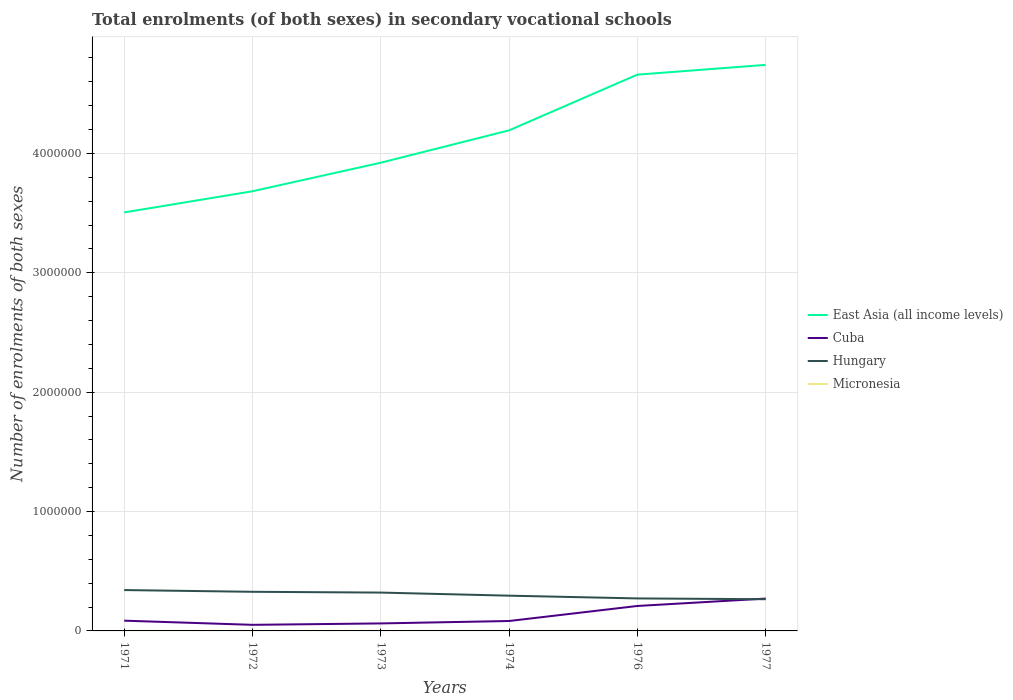How many different coloured lines are there?
Offer a very short reply. 4. Is the number of lines equal to the number of legend labels?
Provide a succinct answer. Yes. Across all years, what is the maximum number of enrolments in secondary schools in Micronesia?
Your response must be concise. 215. In which year was the number of enrolments in secondary schools in Micronesia maximum?
Provide a short and direct response. 1972. What is the total number of enrolments in secondary schools in Micronesia in the graph?
Offer a terse response. 91. What is the difference between the highest and the second highest number of enrolments in secondary schools in Micronesia?
Ensure brevity in your answer.  194. What is the difference between the highest and the lowest number of enrolments in secondary schools in Cuba?
Your answer should be compact. 2. How many lines are there?
Give a very brief answer. 4. How many years are there in the graph?
Offer a terse response. 6. Are the values on the major ticks of Y-axis written in scientific E-notation?
Ensure brevity in your answer.  No. Where does the legend appear in the graph?
Provide a succinct answer. Center right. What is the title of the graph?
Ensure brevity in your answer.  Total enrolments (of both sexes) in secondary vocational schools. Does "Senegal" appear as one of the legend labels in the graph?
Offer a very short reply. No. What is the label or title of the Y-axis?
Provide a succinct answer. Number of enrolments of both sexes. What is the Number of enrolments of both sexes in East Asia (all income levels) in 1971?
Make the answer very short. 3.51e+06. What is the Number of enrolments of both sexes of Cuba in 1971?
Offer a terse response. 8.59e+04. What is the Number of enrolments of both sexes of Hungary in 1971?
Make the answer very short. 3.42e+05. What is the Number of enrolments of both sexes of Micronesia in 1971?
Provide a short and direct response. 409. What is the Number of enrolments of both sexes of East Asia (all income levels) in 1972?
Your answer should be compact. 3.68e+06. What is the Number of enrolments of both sexes of Cuba in 1972?
Offer a very short reply. 5.10e+04. What is the Number of enrolments of both sexes in Hungary in 1972?
Your response must be concise. 3.28e+05. What is the Number of enrolments of both sexes of Micronesia in 1972?
Offer a very short reply. 215. What is the Number of enrolments of both sexes of East Asia (all income levels) in 1973?
Your response must be concise. 3.92e+06. What is the Number of enrolments of both sexes of Cuba in 1973?
Make the answer very short. 6.28e+04. What is the Number of enrolments of both sexes in Hungary in 1973?
Provide a short and direct response. 3.21e+05. What is the Number of enrolments of both sexes of Micronesia in 1973?
Offer a very short reply. 226. What is the Number of enrolments of both sexes in East Asia (all income levels) in 1974?
Keep it short and to the point. 4.19e+06. What is the Number of enrolments of both sexes in Cuba in 1974?
Your answer should be very brief. 8.31e+04. What is the Number of enrolments of both sexes of Hungary in 1974?
Keep it short and to the point. 2.95e+05. What is the Number of enrolments of both sexes in Micronesia in 1974?
Give a very brief answer. 222. What is the Number of enrolments of both sexes of East Asia (all income levels) in 1976?
Ensure brevity in your answer.  4.66e+06. What is the Number of enrolments of both sexes of Cuba in 1976?
Your answer should be compact. 2.09e+05. What is the Number of enrolments of both sexes of Hungary in 1976?
Your answer should be compact. 2.72e+05. What is the Number of enrolments of both sexes of Micronesia in 1976?
Ensure brevity in your answer.  318. What is the Number of enrolments of both sexes of East Asia (all income levels) in 1977?
Ensure brevity in your answer.  4.74e+06. What is the Number of enrolments of both sexes in Cuba in 1977?
Your answer should be compact. 2.71e+05. What is the Number of enrolments of both sexes in Hungary in 1977?
Your answer should be compact. 2.66e+05. What is the Number of enrolments of both sexes in Micronesia in 1977?
Ensure brevity in your answer.  318. Across all years, what is the maximum Number of enrolments of both sexes in East Asia (all income levels)?
Your response must be concise. 4.74e+06. Across all years, what is the maximum Number of enrolments of both sexes in Cuba?
Keep it short and to the point. 2.71e+05. Across all years, what is the maximum Number of enrolments of both sexes of Hungary?
Provide a short and direct response. 3.42e+05. Across all years, what is the maximum Number of enrolments of both sexes of Micronesia?
Your answer should be very brief. 409. Across all years, what is the minimum Number of enrolments of both sexes in East Asia (all income levels)?
Provide a succinct answer. 3.51e+06. Across all years, what is the minimum Number of enrolments of both sexes in Cuba?
Make the answer very short. 5.10e+04. Across all years, what is the minimum Number of enrolments of both sexes of Hungary?
Your response must be concise. 2.66e+05. Across all years, what is the minimum Number of enrolments of both sexes in Micronesia?
Make the answer very short. 215. What is the total Number of enrolments of both sexes in East Asia (all income levels) in the graph?
Offer a very short reply. 2.47e+07. What is the total Number of enrolments of both sexes of Cuba in the graph?
Your response must be concise. 7.63e+05. What is the total Number of enrolments of both sexes of Hungary in the graph?
Your answer should be compact. 1.82e+06. What is the total Number of enrolments of both sexes in Micronesia in the graph?
Offer a terse response. 1708. What is the difference between the Number of enrolments of both sexes in East Asia (all income levels) in 1971 and that in 1972?
Provide a succinct answer. -1.77e+05. What is the difference between the Number of enrolments of both sexes in Cuba in 1971 and that in 1972?
Offer a terse response. 3.49e+04. What is the difference between the Number of enrolments of both sexes in Hungary in 1971 and that in 1972?
Offer a terse response. 1.45e+04. What is the difference between the Number of enrolments of both sexes of Micronesia in 1971 and that in 1972?
Offer a very short reply. 194. What is the difference between the Number of enrolments of both sexes of East Asia (all income levels) in 1971 and that in 1973?
Your response must be concise. -4.17e+05. What is the difference between the Number of enrolments of both sexes in Cuba in 1971 and that in 1973?
Provide a short and direct response. 2.31e+04. What is the difference between the Number of enrolments of both sexes in Hungary in 1971 and that in 1973?
Offer a very short reply. 2.11e+04. What is the difference between the Number of enrolments of both sexes of Micronesia in 1971 and that in 1973?
Offer a terse response. 183. What is the difference between the Number of enrolments of both sexes in East Asia (all income levels) in 1971 and that in 1974?
Give a very brief answer. -6.88e+05. What is the difference between the Number of enrolments of both sexes in Cuba in 1971 and that in 1974?
Your answer should be very brief. 2764. What is the difference between the Number of enrolments of both sexes of Hungary in 1971 and that in 1974?
Make the answer very short. 4.70e+04. What is the difference between the Number of enrolments of both sexes in Micronesia in 1971 and that in 1974?
Ensure brevity in your answer.  187. What is the difference between the Number of enrolments of both sexes of East Asia (all income levels) in 1971 and that in 1976?
Provide a succinct answer. -1.15e+06. What is the difference between the Number of enrolments of both sexes of Cuba in 1971 and that in 1976?
Offer a terse response. -1.23e+05. What is the difference between the Number of enrolments of both sexes of Hungary in 1971 and that in 1976?
Provide a short and direct response. 7.01e+04. What is the difference between the Number of enrolments of both sexes in Micronesia in 1971 and that in 1976?
Your response must be concise. 91. What is the difference between the Number of enrolments of both sexes in East Asia (all income levels) in 1971 and that in 1977?
Make the answer very short. -1.24e+06. What is the difference between the Number of enrolments of both sexes of Cuba in 1971 and that in 1977?
Give a very brief answer. -1.85e+05. What is the difference between the Number of enrolments of both sexes in Hungary in 1971 and that in 1977?
Provide a short and direct response. 7.68e+04. What is the difference between the Number of enrolments of both sexes in Micronesia in 1971 and that in 1977?
Provide a succinct answer. 91. What is the difference between the Number of enrolments of both sexes of East Asia (all income levels) in 1972 and that in 1973?
Provide a short and direct response. -2.39e+05. What is the difference between the Number of enrolments of both sexes of Cuba in 1972 and that in 1973?
Ensure brevity in your answer.  -1.18e+04. What is the difference between the Number of enrolments of both sexes of Hungary in 1972 and that in 1973?
Offer a terse response. 6551. What is the difference between the Number of enrolments of both sexes of Micronesia in 1972 and that in 1973?
Keep it short and to the point. -11. What is the difference between the Number of enrolments of both sexes in East Asia (all income levels) in 1972 and that in 1974?
Provide a succinct answer. -5.10e+05. What is the difference between the Number of enrolments of both sexes in Cuba in 1972 and that in 1974?
Provide a short and direct response. -3.21e+04. What is the difference between the Number of enrolments of both sexes of Hungary in 1972 and that in 1974?
Give a very brief answer. 3.25e+04. What is the difference between the Number of enrolments of both sexes of East Asia (all income levels) in 1972 and that in 1976?
Keep it short and to the point. -9.77e+05. What is the difference between the Number of enrolments of both sexes in Cuba in 1972 and that in 1976?
Offer a very short reply. -1.58e+05. What is the difference between the Number of enrolments of both sexes of Hungary in 1972 and that in 1976?
Provide a succinct answer. 5.56e+04. What is the difference between the Number of enrolments of both sexes in Micronesia in 1972 and that in 1976?
Provide a short and direct response. -103. What is the difference between the Number of enrolments of both sexes in East Asia (all income levels) in 1972 and that in 1977?
Give a very brief answer. -1.06e+06. What is the difference between the Number of enrolments of both sexes in Cuba in 1972 and that in 1977?
Offer a very short reply. -2.20e+05. What is the difference between the Number of enrolments of both sexes of Hungary in 1972 and that in 1977?
Provide a succinct answer. 6.22e+04. What is the difference between the Number of enrolments of both sexes in Micronesia in 1972 and that in 1977?
Make the answer very short. -103. What is the difference between the Number of enrolments of both sexes of East Asia (all income levels) in 1973 and that in 1974?
Provide a succinct answer. -2.71e+05. What is the difference between the Number of enrolments of both sexes in Cuba in 1973 and that in 1974?
Offer a very short reply. -2.03e+04. What is the difference between the Number of enrolments of both sexes of Hungary in 1973 and that in 1974?
Ensure brevity in your answer.  2.59e+04. What is the difference between the Number of enrolments of both sexes in East Asia (all income levels) in 1973 and that in 1976?
Offer a very short reply. -7.38e+05. What is the difference between the Number of enrolments of both sexes in Cuba in 1973 and that in 1976?
Your answer should be compact. -1.46e+05. What is the difference between the Number of enrolments of both sexes in Hungary in 1973 and that in 1976?
Offer a terse response. 4.90e+04. What is the difference between the Number of enrolments of both sexes of Micronesia in 1973 and that in 1976?
Provide a short and direct response. -92. What is the difference between the Number of enrolments of both sexes in East Asia (all income levels) in 1973 and that in 1977?
Provide a succinct answer. -8.20e+05. What is the difference between the Number of enrolments of both sexes of Cuba in 1973 and that in 1977?
Offer a terse response. -2.08e+05. What is the difference between the Number of enrolments of both sexes in Hungary in 1973 and that in 1977?
Offer a terse response. 5.57e+04. What is the difference between the Number of enrolments of both sexes of Micronesia in 1973 and that in 1977?
Ensure brevity in your answer.  -92. What is the difference between the Number of enrolments of both sexes of East Asia (all income levels) in 1974 and that in 1976?
Your answer should be compact. -4.67e+05. What is the difference between the Number of enrolments of both sexes in Cuba in 1974 and that in 1976?
Ensure brevity in your answer.  -1.26e+05. What is the difference between the Number of enrolments of both sexes of Hungary in 1974 and that in 1976?
Provide a short and direct response. 2.31e+04. What is the difference between the Number of enrolments of both sexes in Micronesia in 1974 and that in 1976?
Offer a terse response. -96. What is the difference between the Number of enrolments of both sexes in East Asia (all income levels) in 1974 and that in 1977?
Give a very brief answer. -5.49e+05. What is the difference between the Number of enrolments of both sexes in Cuba in 1974 and that in 1977?
Your answer should be compact. -1.88e+05. What is the difference between the Number of enrolments of both sexes of Hungary in 1974 and that in 1977?
Ensure brevity in your answer.  2.97e+04. What is the difference between the Number of enrolments of both sexes of Micronesia in 1974 and that in 1977?
Offer a very short reply. -96. What is the difference between the Number of enrolments of both sexes in East Asia (all income levels) in 1976 and that in 1977?
Your answer should be very brief. -8.19e+04. What is the difference between the Number of enrolments of both sexes of Cuba in 1976 and that in 1977?
Keep it short and to the point. -6.19e+04. What is the difference between the Number of enrolments of both sexes of Hungary in 1976 and that in 1977?
Your response must be concise. 6666. What is the difference between the Number of enrolments of both sexes of Micronesia in 1976 and that in 1977?
Keep it short and to the point. 0. What is the difference between the Number of enrolments of both sexes in East Asia (all income levels) in 1971 and the Number of enrolments of both sexes in Cuba in 1972?
Your answer should be very brief. 3.45e+06. What is the difference between the Number of enrolments of both sexes of East Asia (all income levels) in 1971 and the Number of enrolments of both sexes of Hungary in 1972?
Your answer should be compact. 3.18e+06. What is the difference between the Number of enrolments of both sexes in East Asia (all income levels) in 1971 and the Number of enrolments of both sexes in Micronesia in 1972?
Your response must be concise. 3.51e+06. What is the difference between the Number of enrolments of both sexes of Cuba in 1971 and the Number of enrolments of both sexes of Hungary in 1972?
Provide a short and direct response. -2.42e+05. What is the difference between the Number of enrolments of both sexes in Cuba in 1971 and the Number of enrolments of both sexes in Micronesia in 1972?
Offer a very short reply. 8.56e+04. What is the difference between the Number of enrolments of both sexes in Hungary in 1971 and the Number of enrolments of both sexes in Micronesia in 1972?
Provide a succinct answer. 3.42e+05. What is the difference between the Number of enrolments of both sexes in East Asia (all income levels) in 1971 and the Number of enrolments of both sexes in Cuba in 1973?
Keep it short and to the point. 3.44e+06. What is the difference between the Number of enrolments of both sexes in East Asia (all income levels) in 1971 and the Number of enrolments of both sexes in Hungary in 1973?
Ensure brevity in your answer.  3.18e+06. What is the difference between the Number of enrolments of both sexes in East Asia (all income levels) in 1971 and the Number of enrolments of both sexes in Micronesia in 1973?
Provide a short and direct response. 3.51e+06. What is the difference between the Number of enrolments of both sexes in Cuba in 1971 and the Number of enrolments of both sexes in Hungary in 1973?
Offer a terse response. -2.35e+05. What is the difference between the Number of enrolments of both sexes of Cuba in 1971 and the Number of enrolments of both sexes of Micronesia in 1973?
Ensure brevity in your answer.  8.56e+04. What is the difference between the Number of enrolments of both sexes of Hungary in 1971 and the Number of enrolments of both sexes of Micronesia in 1973?
Your answer should be compact. 3.42e+05. What is the difference between the Number of enrolments of both sexes in East Asia (all income levels) in 1971 and the Number of enrolments of both sexes in Cuba in 1974?
Offer a very short reply. 3.42e+06. What is the difference between the Number of enrolments of both sexes of East Asia (all income levels) in 1971 and the Number of enrolments of both sexes of Hungary in 1974?
Ensure brevity in your answer.  3.21e+06. What is the difference between the Number of enrolments of both sexes of East Asia (all income levels) in 1971 and the Number of enrolments of both sexes of Micronesia in 1974?
Make the answer very short. 3.51e+06. What is the difference between the Number of enrolments of both sexes of Cuba in 1971 and the Number of enrolments of both sexes of Hungary in 1974?
Offer a very short reply. -2.09e+05. What is the difference between the Number of enrolments of both sexes in Cuba in 1971 and the Number of enrolments of both sexes in Micronesia in 1974?
Provide a short and direct response. 8.56e+04. What is the difference between the Number of enrolments of both sexes of Hungary in 1971 and the Number of enrolments of both sexes of Micronesia in 1974?
Offer a very short reply. 3.42e+05. What is the difference between the Number of enrolments of both sexes in East Asia (all income levels) in 1971 and the Number of enrolments of both sexes in Cuba in 1976?
Offer a very short reply. 3.30e+06. What is the difference between the Number of enrolments of both sexes in East Asia (all income levels) in 1971 and the Number of enrolments of both sexes in Hungary in 1976?
Make the answer very short. 3.23e+06. What is the difference between the Number of enrolments of both sexes of East Asia (all income levels) in 1971 and the Number of enrolments of both sexes of Micronesia in 1976?
Offer a very short reply. 3.51e+06. What is the difference between the Number of enrolments of both sexes in Cuba in 1971 and the Number of enrolments of both sexes in Hungary in 1976?
Your answer should be compact. -1.86e+05. What is the difference between the Number of enrolments of both sexes in Cuba in 1971 and the Number of enrolments of both sexes in Micronesia in 1976?
Your answer should be very brief. 8.55e+04. What is the difference between the Number of enrolments of both sexes of Hungary in 1971 and the Number of enrolments of both sexes of Micronesia in 1976?
Provide a succinct answer. 3.42e+05. What is the difference between the Number of enrolments of both sexes of East Asia (all income levels) in 1971 and the Number of enrolments of both sexes of Cuba in 1977?
Your response must be concise. 3.24e+06. What is the difference between the Number of enrolments of both sexes in East Asia (all income levels) in 1971 and the Number of enrolments of both sexes in Hungary in 1977?
Your answer should be compact. 3.24e+06. What is the difference between the Number of enrolments of both sexes of East Asia (all income levels) in 1971 and the Number of enrolments of both sexes of Micronesia in 1977?
Ensure brevity in your answer.  3.51e+06. What is the difference between the Number of enrolments of both sexes of Cuba in 1971 and the Number of enrolments of both sexes of Hungary in 1977?
Your response must be concise. -1.80e+05. What is the difference between the Number of enrolments of both sexes in Cuba in 1971 and the Number of enrolments of both sexes in Micronesia in 1977?
Your answer should be very brief. 8.55e+04. What is the difference between the Number of enrolments of both sexes of Hungary in 1971 and the Number of enrolments of both sexes of Micronesia in 1977?
Keep it short and to the point. 3.42e+05. What is the difference between the Number of enrolments of both sexes of East Asia (all income levels) in 1972 and the Number of enrolments of both sexes of Cuba in 1973?
Keep it short and to the point. 3.62e+06. What is the difference between the Number of enrolments of both sexes of East Asia (all income levels) in 1972 and the Number of enrolments of both sexes of Hungary in 1973?
Your answer should be very brief. 3.36e+06. What is the difference between the Number of enrolments of both sexes of East Asia (all income levels) in 1972 and the Number of enrolments of both sexes of Micronesia in 1973?
Offer a terse response. 3.68e+06. What is the difference between the Number of enrolments of both sexes of Cuba in 1972 and the Number of enrolments of both sexes of Hungary in 1973?
Keep it short and to the point. -2.70e+05. What is the difference between the Number of enrolments of both sexes of Cuba in 1972 and the Number of enrolments of both sexes of Micronesia in 1973?
Offer a terse response. 5.08e+04. What is the difference between the Number of enrolments of both sexes of Hungary in 1972 and the Number of enrolments of both sexes of Micronesia in 1973?
Give a very brief answer. 3.28e+05. What is the difference between the Number of enrolments of both sexes in East Asia (all income levels) in 1972 and the Number of enrolments of both sexes in Cuba in 1974?
Offer a terse response. 3.60e+06. What is the difference between the Number of enrolments of both sexes in East Asia (all income levels) in 1972 and the Number of enrolments of both sexes in Hungary in 1974?
Your answer should be compact. 3.39e+06. What is the difference between the Number of enrolments of both sexes of East Asia (all income levels) in 1972 and the Number of enrolments of both sexes of Micronesia in 1974?
Offer a very short reply. 3.68e+06. What is the difference between the Number of enrolments of both sexes of Cuba in 1972 and the Number of enrolments of both sexes of Hungary in 1974?
Provide a succinct answer. -2.44e+05. What is the difference between the Number of enrolments of both sexes of Cuba in 1972 and the Number of enrolments of both sexes of Micronesia in 1974?
Your response must be concise. 5.08e+04. What is the difference between the Number of enrolments of both sexes of Hungary in 1972 and the Number of enrolments of both sexes of Micronesia in 1974?
Provide a short and direct response. 3.28e+05. What is the difference between the Number of enrolments of both sexes of East Asia (all income levels) in 1972 and the Number of enrolments of both sexes of Cuba in 1976?
Your answer should be very brief. 3.47e+06. What is the difference between the Number of enrolments of both sexes in East Asia (all income levels) in 1972 and the Number of enrolments of both sexes in Hungary in 1976?
Give a very brief answer. 3.41e+06. What is the difference between the Number of enrolments of both sexes in East Asia (all income levels) in 1972 and the Number of enrolments of both sexes in Micronesia in 1976?
Offer a terse response. 3.68e+06. What is the difference between the Number of enrolments of both sexes in Cuba in 1972 and the Number of enrolments of both sexes in Hungary in 1976?
Your answer should be very brief. -2.21e+05. What is the difference between the Number of enrolments of both sexes in Cuba in 1972 and the Number of enrolments of both sexes in Micronesia in 1976?
Provide a short and direct response. 5.07e+04. What is the difference between the Number of enrolments of both sexes in Hungary in 1972 and the Number of enrolments of both sexes in Micronesia in 1976?
Give a very brief answer. 3.27e+05. What is the difference between the Number of enrolments of both sexes in East Asia (all income levels) in 1972 and the Number of enrolments of both sexes in Cuba in 1977?
Your answer should be compact. 3.41e+06. What is the difference between the Number of enrolments of both sexes in East Asia (all income levels) in 1972 and the Number of enrolments of both sexes in Hungary in 1977?
Ensure brevity in your answer.  3.42e+06. What is the difference between the Number of enrolments of both sexes of East Asia (all income levels) in 1972 and the Number of enrolments of both sexes of Micronesia in 1977?
Your answer should be compact. 3.68e+06. What is the difference between the Number of enrolments of both sexes in Cuba in 1972 and the Number of enrolments of both sexes in Hungary in 1977?
Your response must be concise. -2.15e+05. What is the difference between the Number of enrolments of both sexes of Cuba in 1972 and the Number of enrolments of both sexes of Micronesia in 1977?
Ensure brevity in your answer.  5.07e+04. What is the difference between the Number of enrolments of both sexes of Hungary in 1972 and the Number of enrolments of both sexes of Micronesia in 1977?
Ensure brevity in your answer.  3.27e+05. What is the difference between the Number of enrolments of both sexes of East Asia (all income levels) in 1973 and the Number of enrolments of both sexes of Cuba in 1974?
Your answer should be compact. 3.84e+06. What is the difference between the Number of enrolments of both sexes of East Asia (all income levels) in 1973 and the Number of enrolments of both sexes of Hungary in 1974?
Offer a very short reply. 3.63e+06. What is the difference between the Number of enrolments of both sexes of East Asia (all income levels) in 1973 and the Number of enrolments of both sexes of Micronesia in 1974?
Keep it short and to the point. 3.92e+06. What is the difference between the Number of enrolments of both sexes of Cuba in 1973 and the Number of enrolments of both sexes of Hungary in 1974?
Your response must be concise. -2.33e+05. What is the difference between the Number of enrolments of both sexes in Cuba in 1973 and the Number of enrolments of both sexes in Micronesia in 1974?
Provide a short and direct response. 6.26e+04. What is the difference between the Number of enrolments of both sexes in Hungary in 1973 and the Number of enrolments of both sexes in Micronesia in 1974?
Your answer should be very brief. 3.21e+05. What is the difference between the Number of enrolments of both sexes in East Asia (all income levels) in 1973 and the Number of enrolments of both sexes in Cuba in 1976?
Provide a short and direct response. 3.71e+06. What is the difference between the Number of enrolments of both sexes in East Asia (all income levels) in 1973 and the Number of enrolments of both sexes in Hungary in 1976?
Your response must be concise. 3.65e+06. What is the difference between the Number of enrolments of both sexes in East Asia (all income levels) in 1973 and the Number of enrolments of both sexes in Micronesia in 1976?
Give a very brief answer. 3.92e+06. What is the difference between the Number of enrolments of both sexes of Cuba in 1973 and the Number of enrolments of both sexes of Hungary in 1976?
Keep it short and to the point. -2.09e+05. What is the difference between the Number of enrolments of both sexes of Cuba in 1973 and the Number of enrolments of both sexes of Micronesia in 1976?
Your answer should be very brief. 6.25e+04. What is the difference between the Number of enrolments of both sexes in Hungary in 1973 and the Number of enrolments of both sexes in Micronesia in 1976?
Provide a short and direct response. 3.21e+05. What is the difference between the Number of enrolments of both sexes of East Asia (all income levels) in 1973 and the Number of enrolments of both sexes of Cuba in 1977?
Ensure brevity in your answer.  3.65e+06. What is the difference between the Number of enrolments of both sexes of East Asia (all income levels) in 1973 and the Number of enrolments of both sexes of Hungary in 1977?
Ensure brevity in your answer.  3.66e+06. What is the difference between the Number of enrolments of both sexes of East Asia (all income levels) in 1973 and the Number of enrolments of both sexes of Micronesia in 1977?
Your response must be concise. 3.92e+06. What is the difference between the Number of enrolments of both sexes in Cuba in 1973 and the Number of enrolments of both sexes in Hungary in 1977?
Make the answer very short. -2.03e+05. What is the difference between the Number of enrolments of both sexes in Cuba in 1973 and the Number of enrolments of both sexes in Micronesia in 1977?
Give a very brief answer. 6.25e+04. What is the difference between the Number of enrolments of both sexes of Hungary in 1973 and the Number of enrolments of both sexes of Micronesia in 1977?
Provide a succinct answer. 3.21e+05. What is the difference between the Number of enrolments of both sexes in East Asia (all income levels) in 1974 and the Number of enrolments of both sexes in Cuba in 1976?
Provide a succinct answer. 3.98e+06. What is the difference between the Number of enrolments of both sexes of East Asia (all income levels) in 1974 and the Number of enrolments of both sexes of Hungary in 1976?
Your answer should be very brief. 3.92e+06. What is the difference between the Number of enrolments of both sexes of East Asia (all income levels) in 1974 and the Number of enrolments of both sexes of Micronesia in 1976?
Your answer should be compact. 4.19e+06. What is the difference between the Number of enrolments of both sexes in Cuba in 1974 and the Number of enrolments of both sexes in Hungary in 1976?
Offer a terse response. -1.89e+05. What is the difference between the Number of enrolments of both sexes of Cuba in 1974 and the Number of enrolments of both sexes of Micronesia in 1976?
Offer a very short reply. 8.28e+04. What is the difference between the Number of enrolments of both sexes of Hungary in 1974 and the Number of enrolments of both sexes of Micronesia in 1976?
Offer a very short reply. 2.95e+05. What is the difference between the Number of enrolments of both sexes of East Asia (all income levels) in 1974 and the Number of enrolments of both sexes of Cuba in 1977?
Provide a succinct answer. 3.92e+06. What is the difference between the Number of enrolments of both sexes of East Asia (all income levels) in 1974 and the Number of enrolments of both sexes of Hungary in 1977?
Your answer should be very brief. 3.93e+06. What is the difference between the Number of enrolments of both sexes in East Asia (all income levels) in 1974 and the Number of enrolments of both sexes in Micronesia in 1977?
Your response must be concise. 4.19e+06. What is the difference between the Number of enrolments of both sexes of Cuba in 1974 and the Number of enrolments of both sexes of Hungary in 1977?
Ensure brevity in your answer.  -1.82e+05. What is the difference between the Number of enrolments of both sexes of Cuba in 1974 and the Number of enrolments of both sexes of Micronesia in 1977?
Give a very brief answer. 8.28e+04. What is the difference between the Number of enrolments of both sexes in Hungary in 1974 and the Number of enrolments of both sexes in Micronesia in 1977?
Offer a terse response. 2.95e+05. What is the difference between the Number of enrolments of both sexes in East Asia (all income levels) in 1976 and the Number of enrolments of both sexes in Cuba in 1977?
Your response must be concise. 4.39e+06. What is the difference between the Number of enrolments of both sexes in East Asia (all income levels) in 1976 and the Number of enrolments of both sexes in Hungary in 1977?
Offer a very short reply. 4.39e+06. What is the difference between the Number of enrolments of both sexes of East Asia (all income levels) in 1976 and the Number of enrolments of both sexes of Micronesia in 1977?
Keep it short and to the point. 4.66e+06. What is the difference between the Number of enrolments of both sexes in Cuba in 1976 and the Number of enrolments of both sexes in Hungary in 1977?
Your answer should be very brief. -5.65e+04. What is the difference between the Number of enrolments of both sexes of Cuba in 1976 and the Number of enrolments of both sexes of Micronesia in 1977?
Your answer should be compact. 2.09e+05. What is the difference between the Number of enrolments of both sexes of Hungary in 1976 and the Number of enrolments of both sexes of Micronesia in 1977?
Your response must be concise. 2.72e+05. What is the average Number of enrolments of both sexes in East Asia (all income levels) per year?
Provide a succinct answer. 4.12e+06. What is the average Number of enrolments of both sexes of Cuba per year?
Offer a very short reply. 1.27e+05. What is the average Number of enrolments of both sexes of Hungary per year?
Ensure brevity in your answer.  3.04e+05. What is the average Number of enrolments of both sexes in Micronesia per year?
Make the answer very short. 284.67. In the year 1971, what is the difference between the Number of enrolments of both sexes in East Asia (all income levels) and Number of enrolments of both sexes in Cuba?
Offer a terse response. 3.42e+06. In the year 1971, what is the difference between the Number of enrolments of both sexes of East Asia (all income levels) and Number of enrolments of both sexes of Hungary?
Keep it short and to the point. 3.16e+06. In the year 1971, what is the difference between the Number of enrolments of both sexes in East Asia (all income levels) and Number of enrolments of both sexes in Micronesia?
Give a very brief answer. 3.51e+06. In the year 1971, what is the difference between the Number of enrolments of both sexes of Cuba and Number of enrolments of both sexes of Hungary?
Your answer should be compact. -2.56e+05. In the year 1971, what is the difference between the Number of enrolments of both sexes in Cuba and Number of enrolments of both sexes in Micronesia?
Your answer should be compact. 8.54e+04. In the year 1971, what is the difference between the Number of enrolments of both sexes in Hungary and Number of enrolments of both sexes in Micronesia?
Ensure brevity in your answer.  3.42e+05. In the year 1972, what is the difference between the Number of enrolments of both sexes in East Asia (all income levels) and Number of enrolments of both sexes in Cuba?
Offer a terse response. 3.63e+06. In the year 1972, what is the difference between the Number of enrolments of both sexes in East Asia (all income levels) and Number of enrolments of both sexes in Hungary?
Your answer should be compact. 3.36e+06. In the year 1972, what is the difference between the Number of enrolments of both sexes of East Asia (all income levels) and Number of enrolments of both sexes of Micronesia?
Keep it short and to the point. 3.68e+06. In the year 1972, what is the difference between the Number of enrolments of both sexes in Cuba and Number of enrolments of both sexes in Hungary?
Your answer should be compact. -2.77e+05. In the year 1972, what is the difference between the Number of enrolments of both sexes of Cuba and Number of enrolments of both sexes of Micronesia?
Give a very brief answer. 5.08e+04. In the year 1972, what is the difference between the Number of enrolments of both sexes in Hungary and Number of enrolments of both sexes in Micronesia?
Your answer should be compact. 3.28e+05. In the year 1973, what is the difference between the Number of enrolments of both sexes of East Asia (all income levels) and Number of enrolments of both sexes of Cuba?
Ensure brevity in your answer.  3.86e+06. In the year 1973, what is the difference between the Number of enrolments of both sexes of East Asia (all income levels) and Number of enrolments of both sexes of Hungary?
Offer a terse response. 3.60e+06. In the year 1973, what is the difference between the Number of enrolments of both sexes in East Asia (all income levels) and Number of enrolments of both sexes in Micronesia?
Your answer should be compact. 3.92e+06. In the year 1973, what is the difference between the Number of enrolments of both sexes of Cuba and Number of enrolments of both sexes of Hungary?
Provide a short and direct response. -2.58e+05. In the year 1973, what is the difference between the Number of enrolments of both sexes in Cuba and Number of enrolments of both sexes in Micronesia?
Provide a short and direct response. 6.26e+04. In the year 1973, what is the difference between the Number of enrolments of both sexes in Hungary and Number of enrolments of both sexes in Micronesia?
Offer a very short reply. 3.21e+05. In the year 1974, what is the difference between the Number of enrolments of both sexes in East Asia (all income levels) and Number of enrolments of both sexes in Cuba?
Keep it short and to the point. 4.11e+06. In the year 1974, what is the difference between the Number of enrolments of both sexes of East Asia (all income levels) and Number of enrolments of both sexes of Hungary?
Provide a succinct answer. 3.90e+06. In the year 1974, what is the difference between the Number of enrolments of both sexes of East Asia (all income levels) and Number of enrolments of both sexes of Micronesia?
Provide a succinct answer. 4.19e+06. In the year 1974, what is the difference between the Number of enrolments of both sexes in Cuba and Number of enrolments of both sexes in Hungary?
Your answer should be very brief. -2.12e+05. In the year 1974, what is the difference between the Number of enrolments of both sexes of Cuba and Number of enrolments of both sexes of Micronesia?
Make the answer very short. 8.29e+04. In the year 1974, what is the difference between the Number of enrolments of both sexes of Hungary and Number of enrolments of both sexes of Micronesia?
Provide a short and direct response. 2.95e+05. In the year 1976, what is the difference between the Number of enrolments of both sexes in East Asia (all income levels) and Number of enrolments of both sexes in Cuba?
Your answer should be very brief. 4.45e+06. In the year 1976, what is the difference between the Number of enrolments of both sexes in East Asia (all income levels) and Number of enrolments of both sexes in Hungary?
Your answer should be very brief. 4.39e+06. In the year 1976, what is the difference between the Number of enrolments of both sexes of East Asia (all income levels) and Number of enrolments of both sexes of Micronesia?
Make the answer very short. 4.66e+06. In the year 1976, what is the difference between the Number of enrolments of both sexes of Cuba and Number of enrolments of both sexes of Hungary?
Provide a succinct answer. -6.32e+04. In the year 1976, what is the difference between the Number of enrolments of both sexes of Cuba and Number of enrolments of both sexes of Micronesia?
Ensure brevity in your answer.  2.09e+05. In the year 1976, what is the difference between the Number of enrolments of both sexes in Hungary and Number of enrolments of both sexes in Micronesia?
Your response must be concise. 2.72e+05. In the year 1977, what is the difference between the Number of enrolments of both sexes of East Asia (all income levels) and Number of enrolments of both sexes of Cuba?
Offer a very short reply. 4.47e+06. In the year 1977, what is the difference between the Number of enrolments of both sexes of East Asia (all income levels) and Number of enrolments of both sexes of Hungary?
Give a very brief answer. 4.48e+06. In the year 1977, what is the difference between the Number of enrolments of both sexes in East Asia (all income levels) and Number of enrolments of both sexes in Micronesia?
Provide a short and direct response. 4.74e+06. In the year 1977, what is the difference between the Number of enrolments of both sexes of Cuba and Number of enrolments of both sexes of Hungary?
Your response must be concise. 5364. In the year 1977, what is the difference between the Number of enrolments of both sexes in Cuba and Number of enrolments of both sexes in Micronesia?
Offer a very short reply. 2.71e+05. In the year 1977, what is the difference between the Number of enrolments of both sexes of Hungary and Number of enrolments of both sexes of Micronesia?
Offer a terse response. 2.65e+05. What is the ratio of the Number of enrolments of both sexes in East Asia (all income levels) in 1971 to that in 1972?
Keep it short and to the point. 0.95. What is the ratio of the Number of enrolments of both sexes in Cuba in 1971 to that in 1972?
Your answer should be very brief. 1.68. What is the ratio of the Number of enrolments of both sexes in Hungary in 1971 to that in 1972?
Offer a very short reply. 1.04. What is the ratio of the Number of enrolments of both sexes in Micronesia in 1971 to that in 1972?
Ensure brevity in your answer.  1.9. What is the ratio of the Number of enrolments of both sexes in East Asia (all income levels) in 1971 to that in 1973?
Give a very brief answer. 0.89. What is the ratio of the Number of enrolments of both sexes of Cuba in 1971 to that in 1973?
Your answer should be compact. 1.37. What is the ratio of the Number of enrolments of both sexes in Hungary in 1971 to that in 1973?
Offer a very short reply. 1.07. What is the ratio of the Number of enrolments of both sexes of Micronesia in 1971 to that in 1973?
Keep it short and to the point. 1.81. What is the ratio of the Number of enrolments of both sexes of East Asia (all income levels) in 1971 to that in 1974?
Keep it short and to the point. 0.84. What is the ratio of the Number of enrolments of both sexes in Cuba in 1971 to that in 1974?
Your answer should be very brief. 1.03. What is the ratio of the Number of enrolments of both sexes in Hungary in 1971 to that in 1974?
Keep it short and to the point. 1.16. What is the ratio of the Number of enrolments of both sexes of Micronesia in 1971 to that in 1974?
Make the answer very short. 1.84. What is the ratio of the Number of enrolments of both sexes in East Asia (all income levels) in 1971 to that in 1976?
Keep it short and to the point. 0.75. What is the ratio of the Number of enrolments of both sexes of Cuba in 1971 to that in 1976?
Your answer should be compact. 0.41. What is the ratio of the Number of enrolments of both sexes in Hungary in 1971 to that in 1976?
Your answer should be compact. 1.26. What is the ratio of the Number of enrolments of both sexes of Micronesia in 1971 to that in 1976?
Your response must be concise. 1.29. What is the ratio of the Number of enrolments of both sexes of East Asia (all income levels) in 1971 to that in 1977?
Offer a terse response. 0.74. What is the ratio of the Number of enrolments of both sexes in Cuba in 1971 to that in 1977?
Keep it short and to the point. 0.32. What is the ratio of the Number of enrolments of both sexes of Hungary in 1971 to that in 1977?
Provide a succinct answer. 1.29. What is the ratio of the Number of enrolments of both sexes in Micronesia in 1971 to that in 1977?
Provide a succinct answer. 1.29. What is the ratio of the Number of enrolments of both sexes in East Asia (all income levels) in 1972 to that in 1973?
Ensure brevity in your answer.  0.94. What is the ratio of the Number of enrolments of both sexes of Cuba in 1972 to that in 1973?
Offer a very short reply. 0.81. What is the ratio of the Number of enrolments of both sexes of Hungary in 1972 to that in 1973?
Your response must be concise. 1.02. What is the ratio of the Number of enrolments of both sexes in Micronesia in 1972 to that in 1973?
Offer a terse response. 0.95. What is the ratio of the Number of enrolments of both sexes in East Asia (all income levels) in 1972 to that in 1974?
Offer a terse response. 0.88. What is the ratio of the Number of enrolments of both sexes of Cuba in 1972 to that in 1974?
Ensure brevity in your answer.  0.61. What is the ratio of the Number of enrolments of both sexes in Hungary in 1972 to that in 1974?
Your answer should be very brief. 1.11. What is the ratio of the Number of enrolments of both sexes in Micronesia in 1972 to that in 1974?
Your answer should be very brief. 0.97. What is the ratio of the Number of enrolments of both sexes of East Asia (all income levels) in 1972 to that in 1976?
Offer a very short reply. 0.79. What is the ratio of the Number of enrolments of both sexes in Cuba in 1972 to that in 1976?
Your response must be concise. 0.24. What is the ratio of the Number of enrolments of both sexes in Hungary in 1972 to that in 1976?
Ensure brevity in your answer.  1.2. What is the ratio of the Number of enrolments of both sexes in Micronesia in 1972 to that in 1976?
Your answer should be compact. 0.68. What is the ratio of the Number of enrolments of both sexes in East Asia (all income levels) in 1972 to that in 1977?
Provide a succinct answer. 0.78. What is the ratio of the Number of enrolments of both sexes in Cuba in 1972 to that in 1977?
Give a very brief answer. 0.19. What is the ratio of the Number of enrolments of both sexes in Hungary in 1972 to that in 1977?
Keep it short and to the point. 1.23. What is the ratio of the Number of enrolments of both sexes in Micronesia in 1972 to that in 1977?
Keep it short and to the point. 0.68. What is the ratio of the Number of enrolments of both sexes in East Asia (all income levels) in 1973 to that in 1974?
Offer a very short reply. 0.94. What is the ratio of the Number of enrolments of both sexes in Cuba in 1973 to that in 1974?
Give a very brief answer. 0.76. What is the ratio of the Number of enrolments of both sexes of Hungary in 1973 to that in 1974?
Make the answer very short. 1.09. What is the ratio of the Number of enrolments of both sexes of East Asia (all income levels) in 1973 to that in 1976?
Your response must be concise. 0.84. What is the ratio of the Number of enrolments of both sexes of Cuba in 1973 to that in 1976?
Your answer should be very brief. 0.3. What is the ratio of the Number of enrolments of both sexes in Hungary in 1973 to that in 1976?
Ensure brevity in your answer.  1.18. What is the ratio of the Number of enrolments of both sexes of Micronesia in 1973 to that in 1976?
Your answer should be compact. 0.71. What is the ratio of the Number of enrolments of both sexes in East Asia (all income levels) in 1973 to that in 1977?
Ensure brevity in your answer.  0.83. What is the ratio of the Number of enrolments of both sexes in Cuba in 1973 to that in 1977?
Provide a succinct answer. 0.23. What is the ratio of the Number of enrolments of both sexes of Hungary in 1973 to that in 1977?
Provide a succinct answer. 1.21. What is the ratio of the Number of enrolments of both sexes of Micronesia in 1973 to that in 1977?
Your answer should be very brief. 0.71. What is the ratio of the Number of enrolments of both sexes of East Asia (all income levels) in 1974 to that in 1976?
Provide a succinct answer. 0.9. What is the ratio of the Number of enrolments of both sexes of Cuba in 1974 to that in 1976?
Keep it short and to the point. 0.4. What is the ratio of the Number of enrolments of both sexes of Hungary in 1974 to that in 1976?
Give a very brief answer. 1.08. What is the ratio of the Number of enrolments of both sexes in Micronesia in 1974 to that in 1976?
Provide a succinct answer. 0.7. What is the ratio of the Number of enrolments of both sexes of East Asia (all income levels) in 1974 to that in 1977?
Make the answer very short. 0.88. What is the ratio of the Number of enrolments of both sexes of Cuba in 1974 to that in 1977?
Your answer should be compact. 0.31. What is the ratio of the Number of enrolments of both sexes of Hungary in 1974 to that in 1977?
Keep it short and to the point. 1.11. What is the ratio of the Number of enrolments of both sexes of Micronesia in 1974 to that in 1977?
Your answer should be very brief. 0.7. What is the ratio of the Number of enrolments of both sexes in East Asia (all income levels) in 1976 to that in 1977?
Your response must be concise. 0.98. What is the ratio of the Number of enrolments of both sexes of Cuba in 1976 to that in 1977?
Offer a very short reply. 0.77. What is the ratio of the Number of enrolments of both sexes of Hungary in 1976 to that in 1977?
Your response must be concise. 1.03. What is the ratio of the Number of enrolments of both sexes of Micronesia in 1976 to that in 1977?
Make the answer very short. 1. What is the difference between the highest and the second highest Number of enrolments of both sexes in East Asia (all income levels)?
Provide a succinct answer. 8.19e+04. What is the difference between the highest and the second highest Number of enrolments of both sexes in Cuba?
Ensure brevity in your answer.  6.19e+04. What is the difference between the highest and the second highest Number of enrolments of both sexes of Hungary?
Provide a short and direct response. 1.45e+04. What is the difference between the highest and the second highest Number of enrolments of both sexes in Micronesia?
Your answer should be compact. 91. What is the difference between the highest and the lowest Number of enrolments of both sexes of East Asia (all income levels)?
Make the answer very short. 1.24e+06. What is the difference between the highest and the lowest Number of enrolments of both sexes of Cuba?
Provide a short and direct response. 2.20e+05. What is the difference between the highest and the lowest Number of enrolments of both sexes in Hungary?
Ensure brevity in your answer.  7.68e+04. What is the difference between the highest and the lowest Number of enrolments of both sexes of Micronesia?
Your answer should be very brief. 194. 